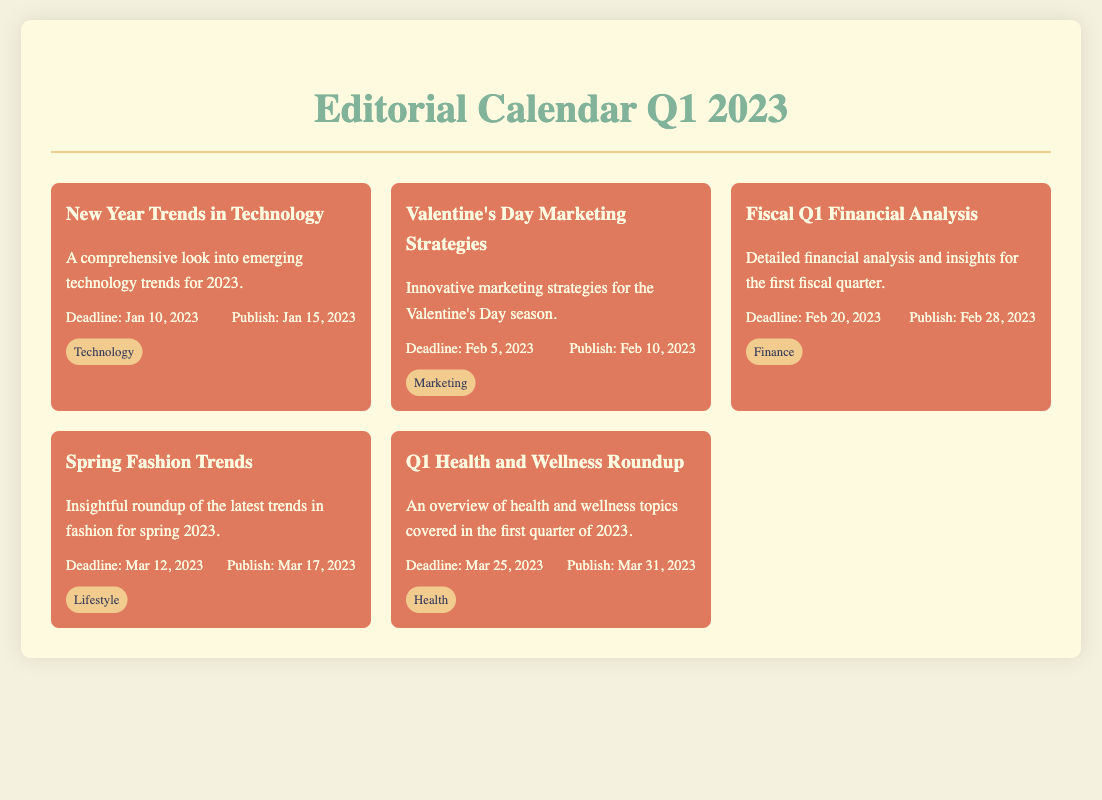What is the title of the first event? The title of the first event is found at the top of the first event section in the calendar.
Answer: New Year Trends in Technology What is the deadline for the Valentine's Day Marketing Strategies event? The deadline for this event is specified in the dates section under the event description.
Answer: Feb 5, 2023 How many days after the deadline is the publish date for the Fiscal Q1 Financial Analysis? The publish date is listed after the deadline, and the difference in days can be calculated.
Answer: 8 days What is the category of the Spring Fashion Trends event? The category is indicated under the event description and identified with a label.
Answer: Lifestyle When is the publish date for the Q1 Health and Wellness Roundup? The publish date is provided in the dates section of the respective event.
Answer: Mar 31, 2023 Which event has a deadline on Mar 12, 2023? The event title can be found by locating the deadline in the calendar.
Answer: Spring Fashion Trends What is the total number of events listed in the calendar? The total number of events can be counted directly from the event sections present in the document.
Answer: 5 events What is the main focus of the New Year Trends in Technology article? The focus of the article is stated in the brief description provided under the title.
Answer: Emerging technology trends for 2023 